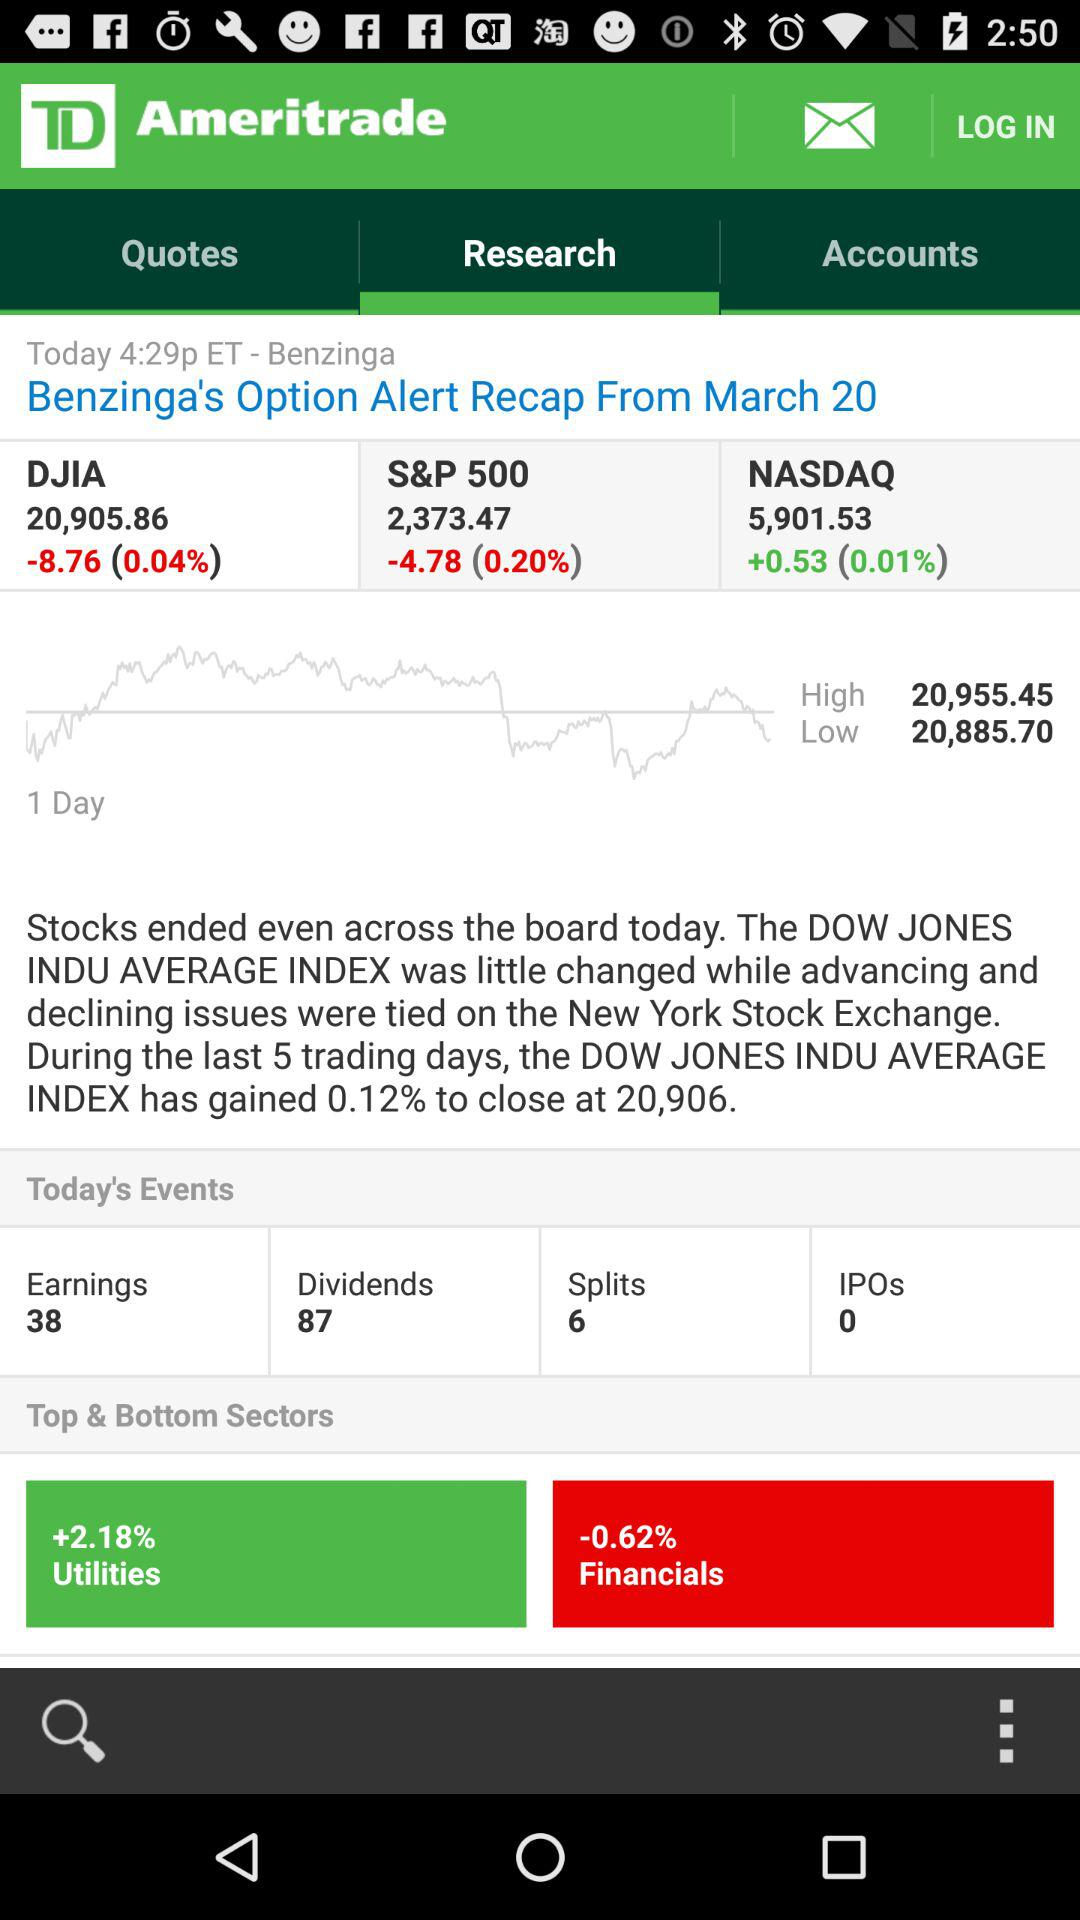What does the red bar labeled 'Financials' indicate? The red bar indicates that the Financials sector experienced a decrease in its value, specifically a drop of 0.62%. Is this a significant drop for the Financials sector? A 0.62% decrease is relatively modest, but for investors holding assets in this sector, it could represent a notable change depending on their portfolio size and the context of this performance within a broader economic analysis. 